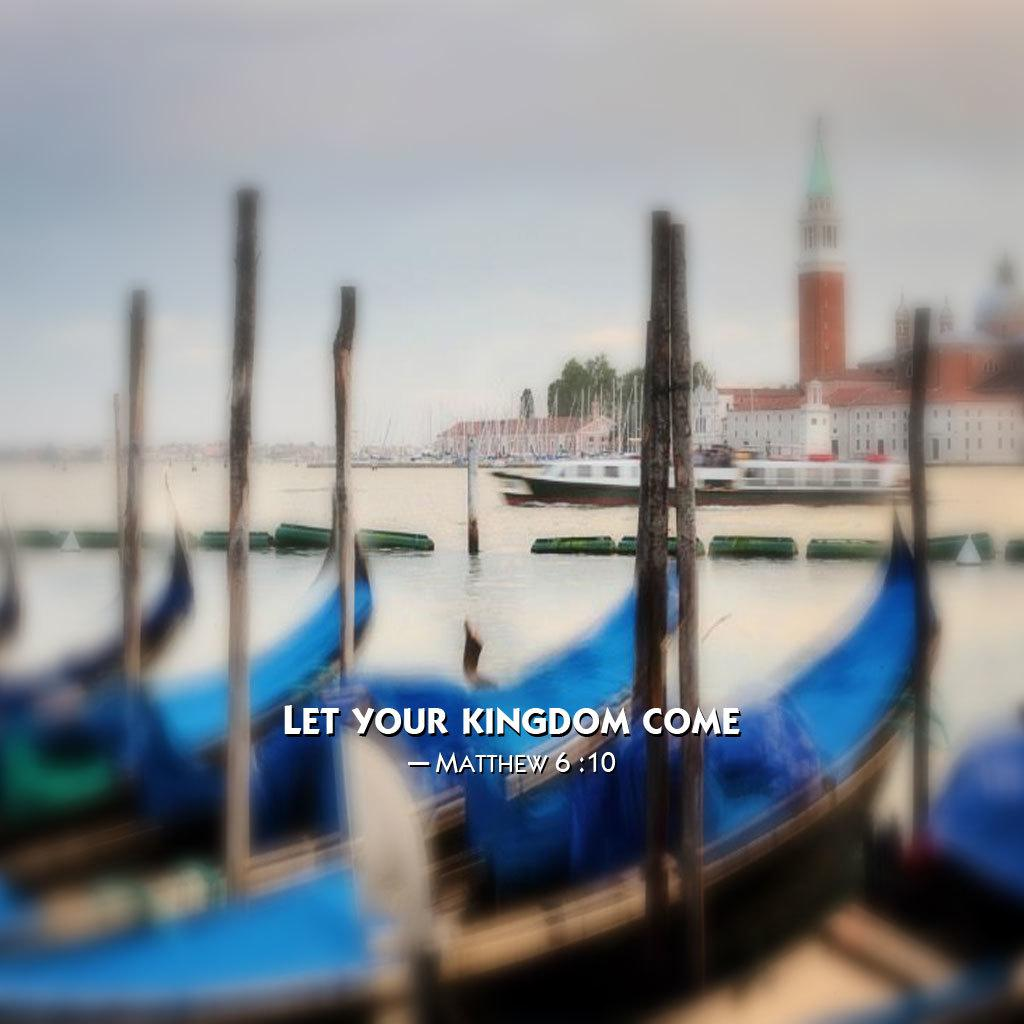What type of vehicles can be seen in the image? There are boats in the image. What is on the water in the image? There are objects on the water in the image, which are the boats. What can be seen in the background of the image? There are buildings, trees, and the sky visible in the background of the image. Is there any indication of the image's origin or ownership? Yes, there is a watermark on the image. How does the water wash the boats in the image? The water does not wash the boats in the image; it is a still image and does not depict any motion or action. 